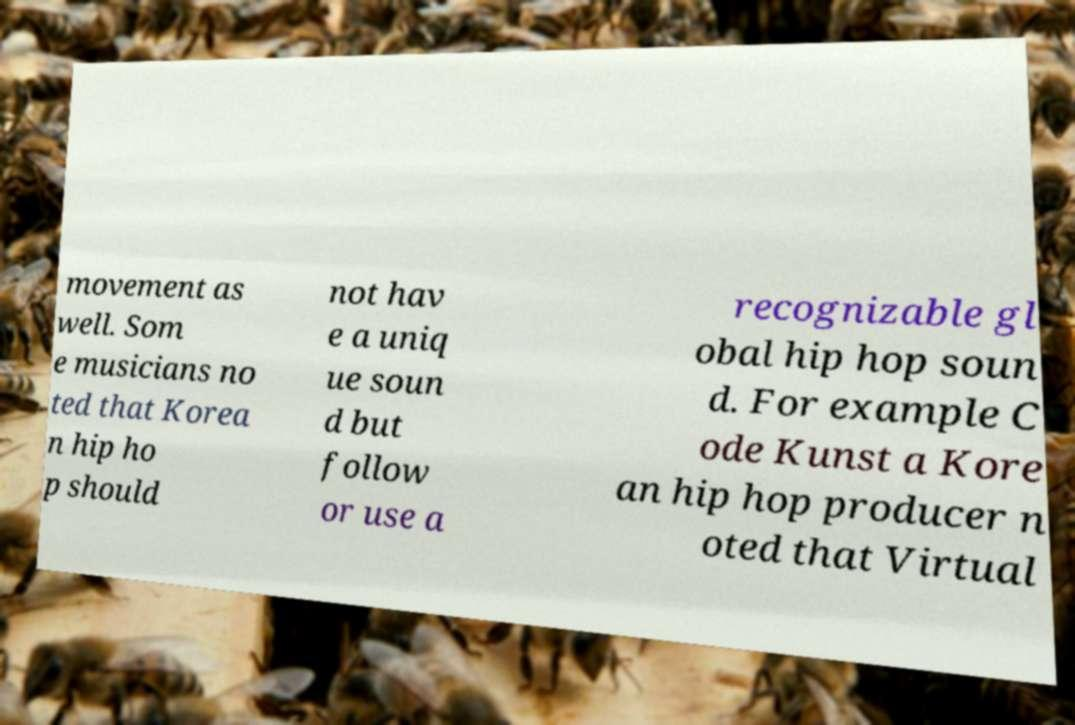There's text embedded in this image that I need extracted. Can you transcribe it verbatim? movement as well. Som e musicians no ted that Korea n hip ho p should not hav e a uniq ue soun d but follow or use a recognizable gl obal hip hop soun d. For example C ode Kunst a Kore an hip hop producer n oted that Virtual 